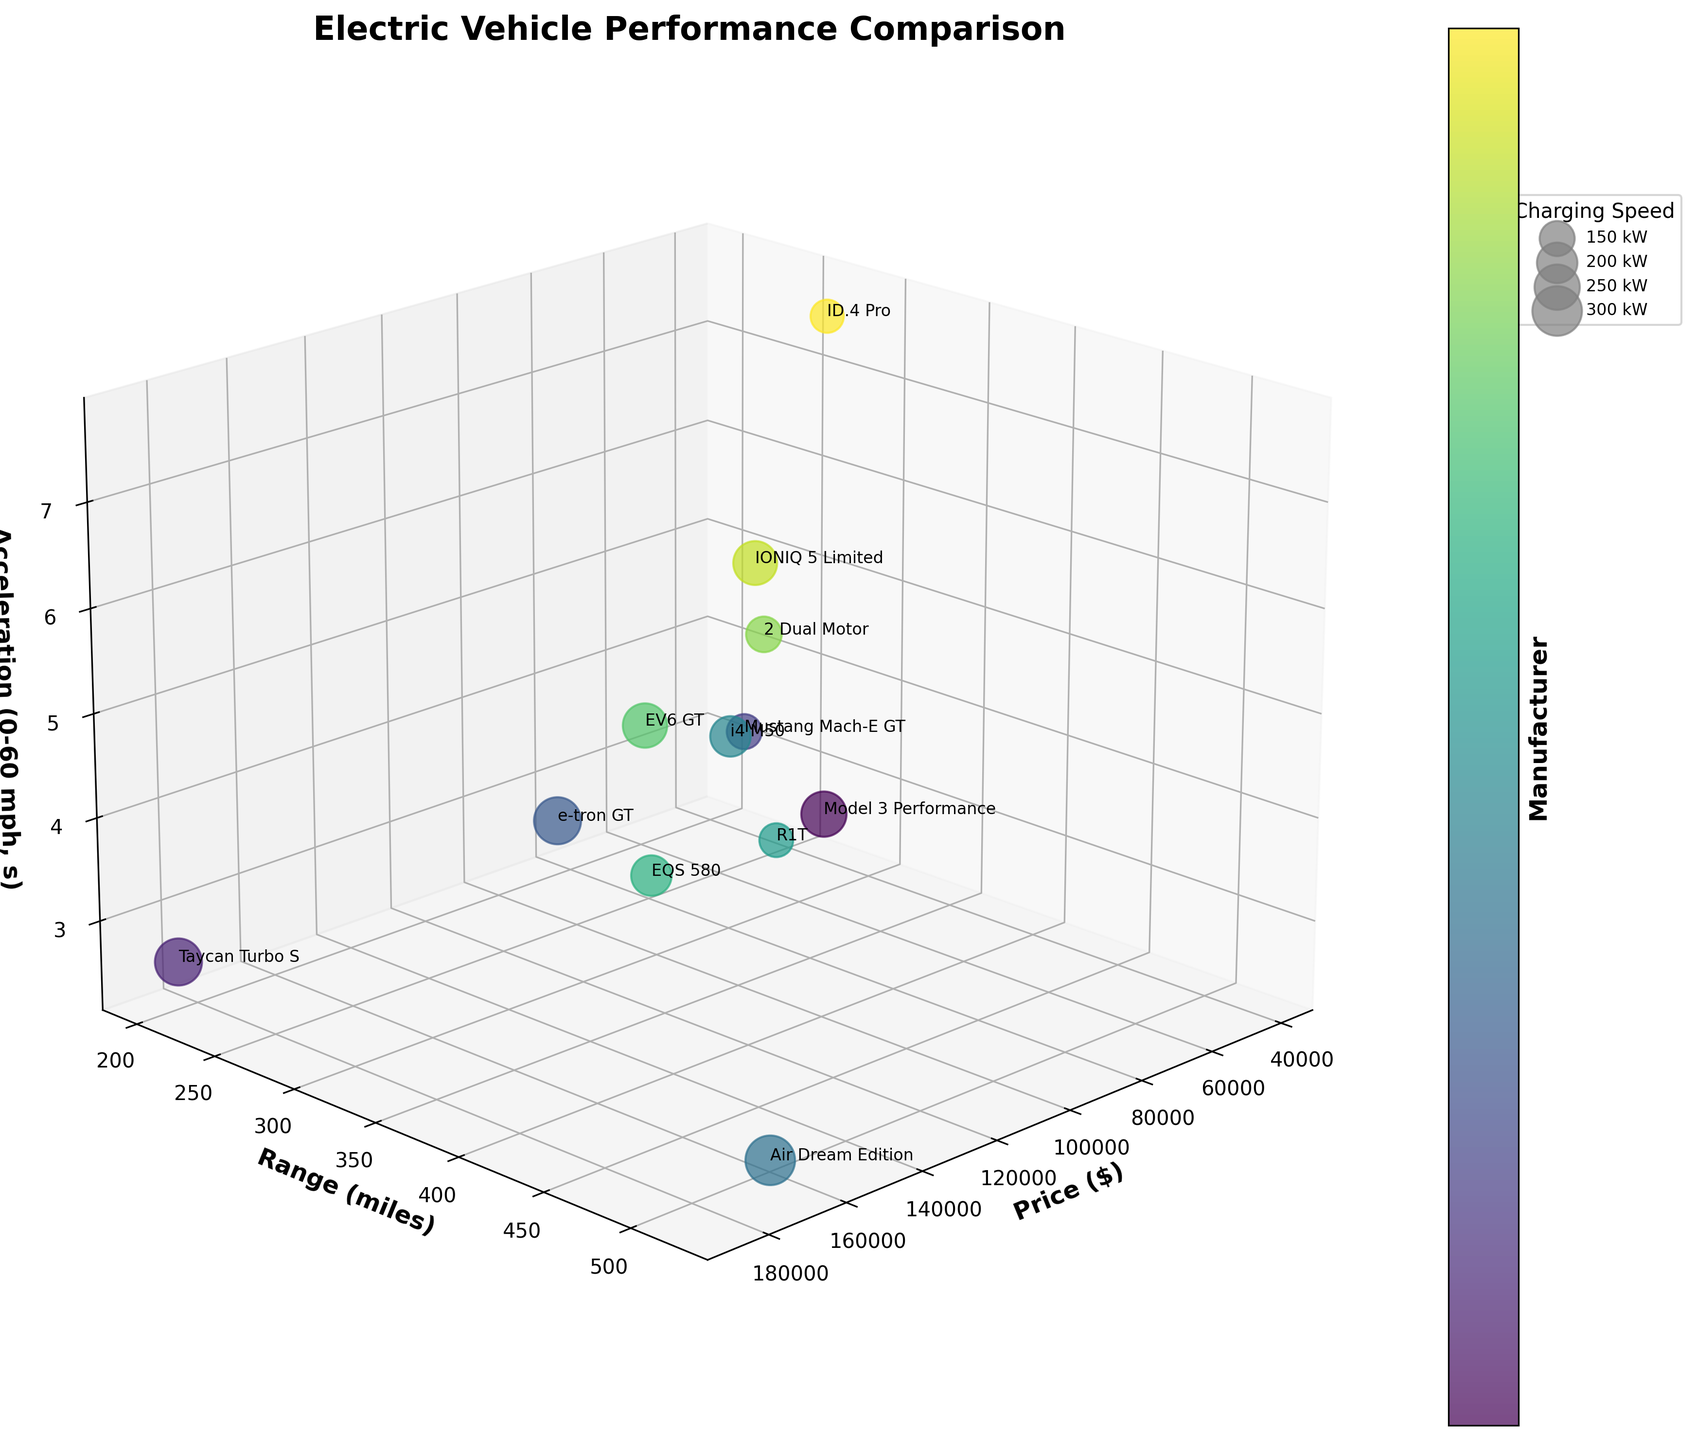What is the title of the chart? The title of any chart is typically located at the top and gives a quick idea of what the chart is about. In this case, it is clearly stated at the top of the 3D bubble chart.
Answer: Electric Vehicle Performance Comparison How many electric vehicle models are compared in the figure? The number of models can be determined by counting the number of individual bubbles or annotations in the chart. Each bubble represents one model.
Answer: 12 Which vehicle has the highest range in miles? The highest range can be found by identifying the bubble positioned farthest along the range axis (y-axis).
Answer: Lucid Air Dream Edition Between the Audi e-tron GT and the Tesla Model 3 Performance, which one has better acceleration? Compare the positions of the two bubbles along the acceleration axis (z-axis). A lower value represents better acceleration.
Answer: Porsche Taycan Turbo S What is the average price of the vehicles plotted? Sum all the vehicle prices and divide by the number of vehicles. The prices are: 59990, 185000, 61995, 99900, 169000, 65900, 73000, 119110, 61400, 51900, 52600, 41230. This gives (59990 + 185000 + 61995 + 99900 + 169000 + 65900 + 73000 + 119110 + 61400 + 51900 + 52600 + 41230) / 12 = 924625 / 12.
Answer: $77052.08 Which model has the fastest charging speed and how much is it? The fastest charging speed is represented by the largest bubble. Locate the model name next to the largest bubble and determine its charging speed.
Answer: Lucid Air Dream Edition, 300 kW What is the price difference between the cheapest and the most expensive vehicle? Identify the vehicles with the lowest and highest prices from the axis labels, then subtract the lowest price from the highest price: 185000 (most expensive) − 41230 (cheapest).
Answer: $143770 How many vehicles have a charging speed of at least 200 kW? Count the number of bubbles with sizes indicating charging speeds of 200 kW or more, as annotated in the legend.
Answer: 7 Which vehicle has the lowest acceleration time, and what is its price? The lowest acceleration time is represented by the bubble closest to the origin of the z-axis. Locate the model name and price next to this bubble.
Answer: Lucid Air Dream Edition, $169000 Between the Polestar 2 Dual Motor and the Volkswagen ID.4 Pro, which one has a longer range? Compare the positions of the two bubbles along the range axis (y-axis). The bubble located farther along the axis has a longer range.
Answer: Volkswagen ID.4 Pro 